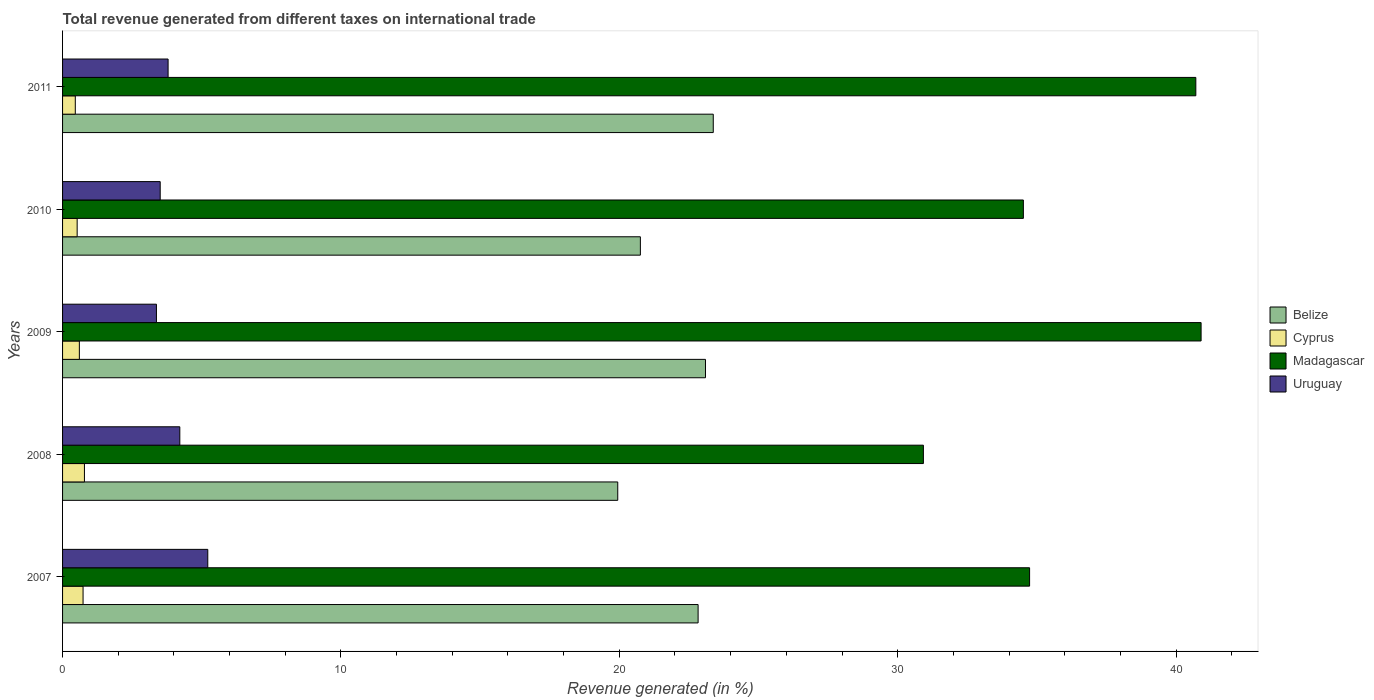How many different coloured bars are there?
Your answer should be compact. 4. How many groups of bars are there?
Your answer should be very brief. 5. How many bars are there on the 5th tick from the top?
Offer a very short reply. 4. What is the label of the 5th group of bars from the top?
Give a very brief answer. 2007. In how many cases, is the number of bars for a given year not equal to the number of legend labels?
Give a very brief answer. 0. What is the total revenue generated in Uruguay in 2011?
Provide a short and direct response. 3.79. Across all years, what is the maximum total revenue generated in Cyprus?
Your answer should be very brief. 0.79. Across all years, what is the minimum total revenue generated in Uruguay?
Make the answer very short. 3.37. In which year was the total revenue generated in Belize minimum?
Provide a succinct answer. 2008. What is the total total revenue generated in Cyprus in the graph?
Offer a terse response. 3.11. What is the difference between the total revenue generated in Uruguay in 2007 and that in 2011?
Give a very brief answer. 1.43. What is the difference between the total revenue generated in Cyprus in 2010 and the total revenue generated in Uruguay in 2011?
Give a very brief answer. -3.27. What is the average total revenue generated in Cyprus per year?
Offer a very short reply. 0.62. In the year 2011, what is the difference between the total revenue generated in Belize and total revenue generated in Uruguay?
Provide a succinct answer. 19.58. What is the ratio of the total revenue generated in Madagascar in 2009 to that in 2011?
Keep it short and to the point. 1. Is the total revenue generated in Cyprus in 2008 less than that in 2011?
Your answer should be very brief. No. Is the difference between the total revenue generated in Belize in 2007 and 2011 greater than the difference between the total revenue generated in Uruguay in 2007 and 2011?
Offer a terse response. No. What is the difference between the highest and the second highest total revenue generated in Uruguay?
Give a very brief answer. 1. What is the difference between the highest and the lowest total revenue generated in Belize?
Provide a succinct answer. 3.43. Is the sum of the total revenue generated in Madagascar in 2007 and 2010 greater than the maximum total revenue generated in Belize across all years?
Provide a short and direct response. Yes. What does the 3rd bar from the top in 2011 represents?
Provide a succinct answer. Cyprus. What does the 2nd bar from the bottom in 2011 represents?
Your answer should be very brief. Cyprus. Is it the case that in every year, the sum of the total revenue generated in Uruguay and total revenue generated in Madagascar is greater than the total revenue generated in Cyprus?
Make the answer very short. Yes. How many bars are there?
Offer a very short reply. 20. Are all the bars in the graph horizontal?
Give a very brief answer. Yes. How many years are there in the graph?
Make the answer very short. 5. Are the values on the major ticks of X-axis written in scientific E-notation?
Offer a terse response. No. Does the graph contain grids?
Your response must be concise. No. How many legend labels are there?
Ensure brevity in your answer.  4. What is the title of the graph?
Ensure brevity in your answer.  Total revenue generated from different taxes on international trade. Does "Kuwait" appear as one of the legend labels in the graph?
Make the answer very short. No. What is the label or title of the X-axis?
Offer a terse response. Revenue generated (in %). What is the Revenue generated (in %) in Belize in 2007?
Your answer should be compact. 22.83. What is the Revenue generated (in %) of Cyprus in 2007?
Make the answer very short. 0.74. What is the Revenue generated (in %) of Madagascar in 2007?
Offer a very short reply. 34.74. What is the Revenue generated (in %) in Uruguay in 2007?
Make the answer very short. 5.22. What is the Revenue generated (in %) in Belize in 2008?
Offer a very short reply. 19.94. What is the Revenue generated (in %) of Cyprus in 2008?
Ensure brevity in your answer.  0.79. What is the Revenue generated (in %) in Madagascar in 2008?
Offer a very short reply. 30.92. What is the Revenue generated (in %) of Uruguay in 2008?
Your answer should be very brief. 4.21. What is the Revenue generated (in %) of Belize in 2009?
Offer a terse response. 23.1. What is the Revenue generated (in %) in Cyprus in 2009?
Provide a succinct answer. 0.6. What is the Revenue generated (in %) of Madagascar in 2009?
Your response must be concise. 40.9. What is the Revenue generated (in %) in Uruguay in 2009?
Your response must be concise. 3.37. What is the Revenue generated (in %) in Belize in 2010?
Your answer should be compact. 20.76. What is the Revenue generated (in %) in Cyprus in 2010?
Your response must be concise. 0.52. What is the Revenue generated (in %) of Madagascar in 2010?
Offer a very short reply. 34.52. What is the Revenue generated (in %) in Uruguay in 2010?
Ensure brevity in your answer.  3.51. What is the Revenue generated (in %) of Belize in 2011?
Offer a terse response. 23.37. What is the Revenue generated (in %) of Cyprus in 2011?
Your response must be concise. 0.46. What is the Revenue generated (in %) in Madagascar in 2011?
Your answer should be compact. 40.71. What is the Revenue generated (in %) in Uruguay in 2011?
Offer a terse response. 3.79. Across all years, what is the maximum Revenue generated (in %) of Belize?
Your answer should be very brief. 23.37. Across all years, what is the maximum Revenue generated (in %) of Cyprus?
Your answer should be compact. 0.79. Across all years, what is the maximum Revenue generated (in %) of Madagascar?
Provide a short and direct response. 40.9. Across all years, what is the maximum Revenue generated (in %) of Uruguay?
Offer a terse response. 5.22. Across all years, what is the minimum Revenue generated (in %) in Belize?
Provide a short and direct response. 19.94. Across all years, what is the minimum Revenue generated (in %) in Cyprus?
Your answer should be compact. 0.46. Across all years, what is the minimum Revenue generated (in %) in Madagascar?
Provide a short and direct response. 30.92. Across all years, what is the minimum Revenue generated (in %) in Uruguay?
Provide a short and direct response. 3.37. What is the total Revenue generated (in %) of Belize in the graph?
Provide a short and direct response. 110. What is the total Revenue generated (in %) of Cyprus in the graph?
Provide a short and direct response. 3.11. What is the total Revenue generated (in %) in Madagascar in the graph?
Ensure brevity in your answer.  181.79. What is the total Revenue generated (in %) in Uruguay in the graph?
Provide a succinct answer. 20.1. What is the difference between the Revenue generated (in %) of Belize in 2007 and that in 2008?
Your answer should be very brief. 2.89. What is the difference between the Revenue generated (in %) in Cyprus in 2007 and that in 2008?
Make the answer very short. -0.05. What is the difference between the Revenue generated (in %) of Madagascar in 2007 and that in 2008?
Give a very brief answer. 3.82. What is the difference between the Revenue generated (in %) of Uruguay in 2007 and that in 2008?
Offer a very short reply. 1. What is the difference between the Revenue generated (in %) of Belize in 2007 and that in 2009?
Make the answer very short. -0.27. What is the difference between the Revenue generated (in %) of Cyprus in 2007 and that in 2009?
Give a very brief answer. 0.13. What is the difference between the Revenue generated (in %) in Madagascar in 2007 and that in 2009?
Provide a succinct answer. -6.16. What is the difference between the Revenue generated (in %) in Uruguay in 2007 and that in 2009?
Your answer should be compact. 1.84. What is the difference between the Revenue generated (in %) of Belize in 2007 and that in 2010?
Ensure brevity in your answer.  2.07. What is the difference between the Revenue generated (in %) in Cyprus in 2007 and that in 2010?
Offer a terse response. 0.21. What is the difference between the Revenue generated (in %) of Madagascar in 2007 and that in 2010?
Your answer should be very brief. 0.22. What is the difference between the Revenue generated (in %) in Uruguay in 2007 and that in 2010?
Give a very brief answer. 1.71. What is the difference between the Revenue generated (in %) in Belize in 2007 and that in 2011?
Give a very brief answer. -0.54. What is the difference between the Revenue generated (in %) of Cyprus in 2007 and that in 2011?
Make the answer very short. 0.28. What is the difference between the Revenue generated (in %) of Madagascar in 2007 and that in 2011?
Give a very brief answer. -5.97. What is the difference between the Revenue generated (in %) of Uruguay in 2007 and that in 2011?
Make the answer very short. 1.43. What is the difference between the Revenue generated (in %) in Belize in 2008 and that in 2009?
Keep it short and to the point. -3.15. What is the difference between the Revenue generated (in %) of Cyprus in 2008 and that in 2009?
Make the answer very short. 0.18. What is the difference between the Revenue generated (in %) of Madagascar in 2008 and that in 2009?
Offer a very short reply. -9.98. What is the difference between the Revenue generated (in %) in Uruguay in 2008 and that in 2009?
Make the answer very short. 0.84. What is the difference between the Revenue generated (in %) of Belize in 2008 and that in 2010?
Your answer should be very brief. -0.81. What is the difference between the Revenue generated (in %) of Cyprus in 2008 and that in 2010?
Your response must be concise. 0.26. What is the difference between the Revenue generated (in %) of Madagascar in 2008 and that in 2010?
Your response must be concise. -3.59. What is the difference between the Revenue generated (in %) of Uruguay in 2008 and that in 2010?
Keep it short and to the point. 0.7. What is the difference between the Revenue generated (in %) in Belize in 2008 and that in 2011?
Make the answer very short. -3.43. What is the difference between the Revenue generated (in %) of Cyprus in 2008 and that in 2011?
Provide a short and direct response. 0.33. What is the difference between the Revenue generated (in %) of Madagascar in 2008 and that in 2011?
Keep it short and to the point. -9.79. What is the difference between the Revenue generated (in %) of Uruguay in 2008 and that in 2011?
Your answer should be compact. 0.42. What is the difference between the Revenue generated (in %) of Belize in 2009 and that in 2010?
Keep it short and to the point. 2.34. What is the difference between the Revenue generated (in %) of Cyprus in 2009 and that in 2010?
Offer a very short reply. 0.08. What is the difference between the Revenue generated (in %) in Madagascar in 2009 and that in 2010?
Make the answer very short. 6.38. What is the difference between the Revenue generated (in %) in Uruguay in 2009 and that in 2010?
Ensure brevity in your answer.  -0.14. What is the difference between the Revenue generated (in %) in Belize in 2009 and that in 2011?
Make the answer very short. -0.28. What is the difference between the Revenue generated (in %) in Cyprus in 2009 and that in 2011?
Make the answer very short. 0.15. What is the difference between the Revenue generated (in %) of Madagascar in 2009 and that in 2011?
Your answer should be very brief. 0.19. What is the difference between the Revenue generated (in %) of Uruguay in 2009 and that in 2011?
Provide a succinct answer. -0.42. What is the difference between the Revenue generated (in %) of Belize in 2010 and that in 2011?
Make the answer very short. -2.62. What is the difference between the Revenue generated (in %) in Cyprus in 2010 and that in 2011?
Your response must be concise. 0.07. What is the difference between the Revenue generated (in %) in Madagascar in 2010 and that in 2011?
Your answer should be compact. -6.2. What is the difference between the Revenue generated (in %) of Uruguay in 2010 and that in 2011?
Give a very brief answer. -0.28. What is the difference between the Revenue generated (in %) in Belize in 2007 and the Revenue generated (in %) in Cyprus in 2008?
Your response must be concise. 22.05. What is the difference between the Revenue generated (in %) of Belize in 2007 and the Revenue generated (in %) of Madagascar in 2008?
Provide a succinct answer. -8.09. What is the difference between the Revenue generated (in %) of Belize in 2007 and the Revenue generated (in %) of Uruguay in 2008?
Make the answer very short. 18.62. What is the difference between the Revenue generated (in %) in Cyprus in 2007 and the Revenue generated (in %) in Madagascar in 2008?
Your answer should be very brief. -30.19. What is the difference between the Revenue generated (in %) of Cyprus in 2007 and the Revenue generated (in %) of Uruguay in 2008?
Offer a terse response. -3.48. What is the difference between the Revenue generated (in %) of Madagascar in 2007 and the Revenue generated (in %) of Uruguay in 2008?
Make the answer very short. 30.53. What is the difference between the Revenue generated (in %) in Belize in 2007 and the Revenue generated (in %) in Cyprus in 2009?
Offer a very short reply. 22.23. What is the difference between the Revenue generated (in %) in Belize in 2007 and the Revenue generated (in %) in Madagascar in 2009?
Provide a short and direct response. -18.07. What is the difference between the Revenue generated (in %) of Belize in 2007 and the Revenue generated (in %) of Uruguay in 2009?
Keep it short and to the point. 19.46. What is the difference between the Revenue generated (in %) in Cyprus in 2007 and the Revenue generated (in %) in Madagascar in 2009?
Make the answer very short. -40.16. What is the difference between the Revenue generated (in %) of Cyprus in 2007 and the Revenue generated (in %) of Uruguay in 2009?
Make the answer very short. -2.64. What is the difference between the Revenue generated (in %) in Madagascar in 2007 and the Revenue generated (in %) in Uruguay in 2009?
Provide a succinct answer. 31.37. What is the difference between the Revenue generated (in %) of Belize in 2007 and the Revenue generated (in %) of Cyprus in 2010?
Keep it short and to the point. 22.31. What is the difference between the Revenue generated (in %) of Belize in 2007 and the Revenue generated (in %) of Madagascar in 2010?
Keep it short and to the point. -11.68. What is the difference between the Revenue generated (in %) in Belize in 2007 and the Revenue generated (in %) in Uruguay in 2010?
Your answer should be very brief. 19.32. What is the difference between the Revenue generated (in %) in Cyprus in 2007 and the Revenue generated (in %) in Madagascar in 2010?
Keep it short and to the point. -33.78. What is the difference between the Revenue generated (in %) in Cyprus in 2007 and the Revenue generated (in %) in Uruguay in 2010?
Your answer should be very brief. -2.77. What is the difference between the Revenue generated (in %) of Madagascar in 2007 and the Revenue generated (in %) of Uruguay in 2010?
Offer a terse response. 31.23. What is the difference between the Revenue generated (in %) of Belize in 2007 and the Revenue generated (in %) of Cyprus in 2011?
Offer a terse response. 22.37. What is the difference between the Revenue generated (in %) of Belize in 2007 and the Revenue generated (in %) of Madagascar in 2011?
Give a very brief answer. -17.88. What is the difference between the Revenue generated (in %) in Belize in 2007 and the Revenue generated (in %) in Uruguay in 2011?
Your response must be concise. 19.04. What is the difference between the Revenue generated (in %) of Cyprus in 2007 and the Revenue generated (in %) of Madagascar in 2011?
Keep it short and to the point. -39.97. What is the difference between the Revenue generated (in %) of Cyprus in 2007 and the Revenue generated (in %) of Uruguay in 2011?
Give a very brief answer. -3.05. What is the difference between the Revenue generated (in %) in Madagascar in 2007 and the Revenue generated (in %) in Uruguay in 2011?
Your answer should be very brief. 30.95. What is the difference between the Revenue generated (in %) of Belize in 2008 and the Revenue generated (in %) of Cyprus in 2009?
Keep it short and to the point. 19.34. What is the difference between the Revenue generated (in %) of Belize in 2008 and the Revenue generated (in %) of Madagascar in 2009?
Keep it short and to the point. -20.96. What is the difference between the Revenue generated (in %) in Belize in 2008 and the Revenue generated (in %) in Uruguay in 2009?
Your answer should be very brief. 16.57. What is the difference between the Revenue generated (in %) of Cyprus in 2008 and the Revenue generated (in %) of Madagascar in 2009?
Make the answer very short. -40.11. What is the difference between the Revenue generated (in %) in Cyprus in 2008 and the Revenue generated (in %) in Uruguay in 2009?
Offer a very short reply. -2.59. What is the difference between the Revenue generated (in %) in Madagascar in 2008 and the Revenue generated (in %) in Uruguay in 2009?
Offer a very short reply. 27.55. What is the difference between the Revenue generated (in %) in Belize in 2008 and the Revenue generated (in %) in Cyprus in 2010?
Offer a terse response. 19.42. What is the difference between the Revenue generated (in %) of Belize in 2008 and the Revenue generated (in %) of Madagascar in 2010?
Offer a very short reply. -14.57. What is the difference between the Revenue generated (in %) in Belize in 2008 and the Revenue generated (in %) in Uruguay in 2010?
Provide a succinct answer. 16.44. What is the difference between the Revenue generated (in %) of Cyprus in 2008 and the Revenue generated (in %) of Madagascar in 2010?
Offer a terse response. -33.73. What is the difference between the Revenue generated (in %) of Cyprus in 2008 and the Revenue generated (in %) of Uruguay in 2010?
Keep it short and to the point. -2.72. What is the difference between the Revenue generated (in %) in Madagascar in 2008 and the Revenue generated (in %) in Uruguay in 2010?
Keep it short and to the point. 27.42. What is the difference between the Revenue generated (in %) of Belize in 2008 and the Revenue generated (in %) of Cyprus in 2011?
Provide a succinct answer. 19.49. What is the difference between the Revenue generated (in %) of Belize in 2008 and the Revenue generated (in %) of Madagascar in 2011?
Offer a terse response. -20.77. What is the difference between the Revenue generated (in %) of Belize in 2008 and the Revenue generated (in %) of Uruguay in 2011?
Provide a succinct answer. 16.15. What is the difference between the Revenue generated (in %) in Cyprus in 2008 and the Revenue generated (in %) in Madagascar in 2011?
Ensure brevity in your answer.  -39.92. What is the difference between the Revenue generated (in %) in Cyprus in 2008 and the Revenue generated (in %) in Uruguay in 2011?
Provide a succinct answer. -3.01. What is the difference between the Revenue generated (in %) of Madagascar in 2008 and the Revenue generated (in %) of Uruguay in 2011?
Make the answer very short. 27.13. What is the difference between the Revenue generated (in %) in Belize in 2009 and the Revenue generated (in %) in Cyprus in 2010?
Give a very brief answer. 22.57. What is the difference between the Revenue generated (in %) in Belize in 2009 and the Revenue generated (in %) in Madagascar in 2010?
Provide a short and direct response. -11.42. What is the difference between the Revenue generated (in %) of Belize in 2009 and the Revenue generated (in %) of Uruguay in 2010?
Provide a succinct answer. 19.59. What is the difference between the Revenue generated (in %) in Cyprus in 2009 and the Revenue generated (in %) in Madagascar in 2010?
Ensure brevity in your answer.  -33.91. What is the difference between the Revenue generated (in %) in Cyprus in 2009 and the Revenue generated (in %) in Uruguay in 2010?
Your response must be concise. -2.9. What is the difference between the Revenue generated (in %) in Madagascar in 2009 and the Revenue generated (in %) in Uruguay in 2010?
Offer a terse response. 37.39. What is the difference between the Revenue generated (in %) in Belize in 2009 and the Revenue generated (in %) in Cyprus in 2011?
Make the answer very short. 22.64. What is the difference between the Revenue generated (in %) in Belize in 2009 and the Revenue generated (in %) in Madagascar in 2011?
Make the answer very short. -17.61. What is the difference between the Revenue generated (in %) in Belize in 2009 and the Revenue generated (in %) in Uruguay in 2011?
Offer a terse response. 19.3. What is the difference between the Revenue generated (in %) in Cyprus in 2009 and the Revenue generated (in %) in Madagascar in 2011?
Ensure brevity in your answer.  -40.11. What is the difference between the Revenue generated (in %) in Cyprus in 2009 and the Revenue generated (in %) in Uruguay in 2011?
Offer a terse response. -3.19. What is the difference between the Revenue generated (in %) of Madagascar in 2009 and the Revenue generated (in %) of Uruguay in 2011?
Make the answer very short. 37.11. What is the difference between the Revenue generated (in %) in Belize in 2010 and the Revenue generated (in %) in Cyprus in 2011?
Keep it short and to the point. 20.3. What is the difference between the Revenue generated (in %) of Belize in 2010 and the Revenue generated (in %) of Madagascar in 2011?
Provide a short and direct response. -19.95. What is the difference between the Revenue generated (in %) in Belize in 2010 and the Revenue generated (in %) in Uruguay in 2011?
Give a very brief answer. 16.97. What is the difference between the Revenue generated (in %) of Cyprus in 2010 and the Revenue generated (in %) of Madagascar in 2011?
Provide a succinct answer. -40.19. What is the difference between the Revenue generated (in %) of Cyprus in 2010 and the Revenue generated (in %) of Uruguay in 2011?
Keep it short and to the point. -3.27. What is the difference between the Revenue generated (in %) in Madagascar in 2010 and the Revenue generated (in %) in Uruguay in 2011?
Your response must be concise. 30.72. What is the average Revenue generated (in %) of Belize per year?
Your response must be concise. 22. What is the average Revenue generated (in %) in Cyprus per year?
Offer a terse response. 0.62. What is the average Revenue generated (in %) in Madagascar per year?
Ensure brevity in your answer.  36.36. What is the average Revenue generated (in %) in Uruguay per year?
Keep it short and to the point. 4.02. In the year 2007, what is the difference between the Revenue generated (in %) in Belize and Revenue generated (in %) in Cyprus?
Your answer should be very brief. 22.09. In the year 2007, what is the difference between the Revenue generated (in %) of Belize and Revenue generated (in %) of Madagascar?
Your answer should be compact. -11.91. In the year 2007, what is the difference between the Revenue generated (in %) of Belize and Revenue generated (in %) of Uruguay?
Your answer should be compact. 17.61. In the year 2007, what is the difference between the Revenue generated (in %) in Cyprus and Revenue generated (in %) in Madagascar?
Give a very brief answer. -34. In the year 2007, what is the difference between the Revenue generated (in %) in Cyprus and Revenue generated (in %) in Uruguay?
Your answer should be compact. -4.48. In the year 2007, what is the difference between the Revenue generated (in %) of Madagascar and Revenue generated (in %) of Uruguay?
Offer a terse response. 29.52. In the year 2008, what is the difference between the Revenue generated (in %) in Belize and Revenue generated (in %) in Cyprus?
Offer a very short reply. 19.16. In the year 2008, what is the difference between the Revenue generated (in %) in Belize and Revenue generated (in %) in Madagascar?
Provide a succinct answer. -10.98. In the year 2008, what is the difference between the Revenue generated (in %) in Belize and Revenue generated (in %) in Uruguay?
Give a very brief answer. 15.73. In the year 2008, what is the difference between the Revenue generated (in %) in Cyprus and Revenue generated (in %) in Madagascar?
Make the answer very short. -30.14. In the year 2008, what is the difference between the Revenue generated (in %) in Cyprus and Revenue generated (in %) in Uruguay?
Offer a very short reply. -3.43. In the year 2008, what is the difference between the Revenue generated (in %) of Madagascar and Revenue generated (in %) of Uruguay?
Offer a terse response. 26.71. In the year 2009, what is the difference between the Revenue generated (in %) in Belize and Revenue generated (in %) in Cyprus?
Your answer should be compact. 22.49. In the year 2009, what is the difference between the Revenue generated (in %) of Belize and Revenue generated (in %) of Madagascar?
Your response must be concise. -17.8. In the year 2009, what is the difference between the Revenue generated (in %) in Belize and Revenue generated (in %) in Uruguay?
Ensure brevity in your answer.  19.72. In the year 2009, what is the difference between the Revenue generated (in %) in Cyprus and Revenue generated (in %) in Madagascar?
Offer a very short reply. -40.3. In the year 2009, what is the difference between the Revenue generated (in %) in Cyprus and Revenue generated (in %) in Uruguay?
Offer a very short reply. -2.77. In the year 2009, what is the difference between the Revenue generated (in %) of Madagascar and Revenue generated (in %) of Uruguay?
Keep it short and to the point. 37.53. In the year 2010, what is the difference between the Revenue generated (in %) of Belize and Revenue generated (in %) of Cyprus?
Keep it short and to the point. 20.23. In the year 2010, what is the difference between the Revenue generated (in %) in Belize and Revenue generated (in %) in Madagascar?
Your answer should be very brief. -13.76. In the year 2010, what is the difference between the Revenue generated (in %) in Belize and Revenue generated (in %) in Uruguay?
Ensure brevity in your answer.  17.25. In the year 2010, what is the difference between the Revenue generated (in %) in Cyprus and Revenue generated (in %) in Madagascar?
Your answer should be compact. -33.99. In the year 2010, what is the difference between the Revenue generated (in %) in Cyprus and Revenue generated (in %) in Uruguay?
Provide a succinct answer. -2.98. In the year 2010, what is the difference between the Revenue generated (in %) of Madagascar and Revenue generated (in %) of Uruguay?
Provide a short and direct response. 31.01. In the year 2011, what is the difference between the Revenue generated (in %) in Belize and Revenue generated (in %) in Cyprus?
Provide a succinct answer. 22.92. In the year 2011, what is the difference between the Revenue generated (in %) in Belize and Revenue generated (in %) in Madagascar?
Offer a terse response. -17.34. In the year 2011, what is the difference between the Revenue generated (in %) of Belize and Revenue generated (in %) of Uruguay?
Give a very brief answer. 19.58. In the year 2011, what is the difference between the Revenue generated (in %) of Cyprus and Revenue generated (in %) of Madagascar?
Ensure brevity in your answer.  -40.25. In the year 2011, what is the difference between the Revenue generated (in %) of Cyprus and Revenue generated (in %) of Uruguay?
Your response must be concise. -3.33. In the year 2011, what is the difference between the Revenue generated (in %) in Madagascar and Revenue generated (in %) in Uruguay?
Make the answer very short. 36.92. What is the ratio of the Revenue generated (in %) of Belize in 2007 to that in 2008?
Provide a short and direct response. 1.14. What is the ratio of the Revenue generated (in %) of Cyprus in 2007 to that in 2008?
Offer a very short reply. 0.94. What is the ratio of the Revenue generated (in %) of Madagascar in 2007 to that in 2008?
Your answer should be very brief. 1.12. What is the ratio of the Revenue generated (in %) of Uruguay in 2007 to that in 2008?
Offer a very short reply. 1.24. What is the ratio of the Revenue generated (in %) in Belize in 2007 to that in 2009?
Keep it short and to the point. 0.99. What is the ratio of the Revenue generated (in %) of Cyprus in 2007 to that in 2009?
Ensure brevity in your answer.  1.22. What is the ratio of the Revenue generated (in %) in Madagascar in 2007 to that in 2009?
Make the answer very short. 0.85. What is the ratio of the Revenue generated (in %) in Uruguay in 2007 to that in 2009?
Provide a short and direct response. 1.55. What is the ratio of the Revenue generated (in %) in Belize in 2007 to that in 2010?
Offer a very short reply. 1.1. What is the ratio of the Revenue generated (in %) in Cyprus in 2007 to that in 2010?
Your response must be concise. 1.41. What is the ratio of the Revenue generated (in %) of Madagascar in 2007 to that in 2010?
Ensure brevity in your answer.  1.01. What is the ratio of the Revenue generated (in %) of Uruguay in 2007 to that in 2010?
Give a very brief answer. 1.49. What is the ratio of the Revenue generated (in %) in Belize in 2007 to that in 2011?
Your answer should be very brief. 0.98. What is the ratio of the Revenue generated (in %) of Cyprus in 2007 to that in 2011?
Make the answer very short. 1.61. What is the ratio of the Revenue generated (in %) in Madagascar in 2007 to that in 2011?
Keep it short and to the point. 0.85. What is the ratio of the Revenue generated (in %) in Uruguay in 2007 to that in 2011?
Your answer should be very brief. 1.38. What is the ratio of the Revenue generated (in %) in Belize in 2008 to that in 2009?
Ensure brevity in your answer.  0.86. What is the ratio of the Revenue generated (in %) in Cyprus in 2008 to that in 2009?
Keep it short and to the point. 1.3. What is the ratio of the Revenue generated (in %) in Madagascar in 2008 to that in 2009?
Ensure brevity in your answer.  0.76. What is the ratio of the Revenue generated (in %) of Uruguay in 2008 to that in 2009?
Your response must be concise. 1.25. What is the ratio of the Revenue generated (in %) of Belize in 2008 to that in 2010?
Your answer should be compact. 0.96. What is the ratio of the Revenue generated (in %) in Cyprus in 2008 to that in 2010?
Give a very brief answer. 1.5. What is the ratio of the Revenue generated (in %) of Madagascar in 2008 to that in 2010?
Give a very brief answer. 0.9. What is the ratio of the Revenue generated (in %) in Uruguay in 2008 to that in 2010?
Your answer should be compact. 1.2. What is the ratio of the Revenue generated (in %) of Belize in 2008 to that in 2011?
Your answer should be compact. 0.85. What is the ratio of the Revenue generated (in %) in Cyprus in 2008 to that in 2011?
Provide a succinct answer. 1.72. What is the ratio of the Revenue generated (in %) in Madagascar in 2008 to that in 2011?
Make the answer very short. 0.76. What is the ratio of the Revenue generated (in %) of Uruguay in 2008 to that in 2011?
Provide a short and direct response. 1.11. What is the ratio of the Revenue generated (in %) in Belize in 2009 to that in 2010?
Keep it short and to the point. 1.11. What is the ratio of the Revenue generated (in %) of Cyprus in 2009 to that in 2010?
Your response must be concise. 1.15. What is the ratio of the Revenue generated (in %) of Madagascar in 2009 to that in 2010?
Your answer should be compact. 1.19. What is the ratio of the Revenue generated (in %) of Uruguay in 2009 to that in 2010?
Ensure brevity in your answer.  0.96. What is the ratio of the Revenue generated (in %) in Cyprus in 2009 to that in 2011?
Your answer should be compact. 1.32. What is the ratio of the Revenue generated (in %) in Uruguay in 2009 to that in 2011?
Offer a terse response. 0.89. What is the ratio of the Revenue generated (in %) in Belize in 2010 to that in 2011?
Keep it short and to the point. 0.89. What is the ratio of the Revenue generated (in %) of Cyprus in 2010 to that in 2011?
Give a very brief answer. 1.15. What is the ratio of the Revenue generated (in %) in Madagascar in 2010 to that in 2011?
Your response must be concise. 0.85. What is the ratio of the Revenue generated (in %) of Uruguay in 2010 to that in 2011?
Provide a succinct answer. 0.93. What is the difference between the highest and the second highest Revenue generated (in %) of Belize?
Provide a short and direct response. 0.28. What is the difference between the highest and the second highest Revenue generated (in %) in Cyprus?
Give a very brief answer. 0.05. What is the difference between the highest and the second highest Revenue generated (in %) in Madagascar?
Your response must be concise. 0.19. What is the difference between the highest and the lowest Revenue generated (in %) of Belize?
Ensure brevity in your answer.  3.43. What is the difference between the highest and the lowest Revenue generated (in %) in Cyprus?
Give a very brief answer. 0.33. What is the difference between the highest and the lowest Revenue generated (in %) in Madagascar?
Offer a very short reply. 9.98. What is the difference between the highest and the lowest Revenue generated (in %) in Uruguay?
Provide a succinct answer. 1.84. 